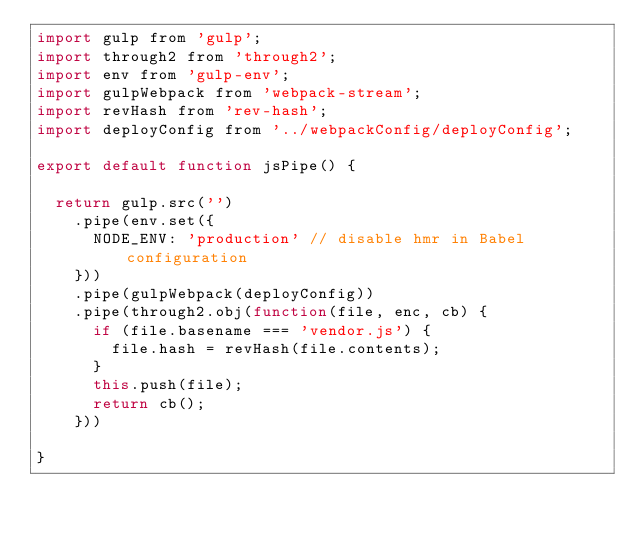<code> <loc_0><loc_0><loc_500><loc_500><_JavaScript_>import gulp from 'gulp';
import through2 from 'through2';
import env from 'gulp-env';
import gulpWebpack from 'webpack-stream';
import revHash from 'rev-hash';
import deployConfig from '../webpackConfig/deployConfig';

export default function jsPipe() {

  return gulp.src('')
    .pipe(env.set({
      NODE_ENV: 'production' // disable hmr in Babel configuration
    }))
    .pipe(gulpWebpack(deployConfig))
    .pipe(through2.obj(function(file, enc, cb) {
      if (file.basename === 'vendor.js') {
        file.hash = revHash(file.contents);
      }
      this.push(file);
      return cb();
    }))

}
</code> 